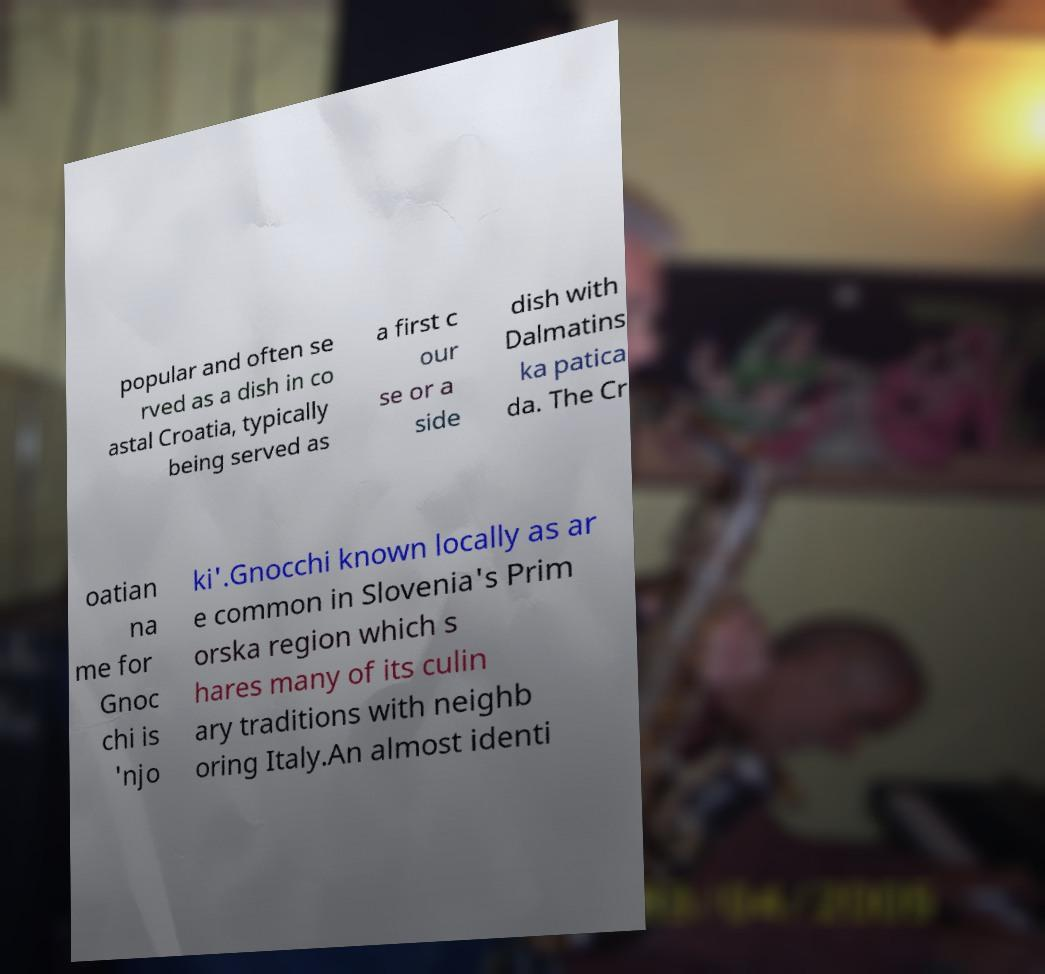Could you extract and type out the text from this image? popular and often se rved as a dish in co astal Croatia, typically being served as a first c our se or a side dish with Dalmatins ka patica da. The Cr oatian na me for Gnoc chi is 'njo ki'.Gnocchi known locally as ar e common in Slovenia's Prim orska region which s hares many of its culin ary traditions with neighb oring Italy.An almost identi 